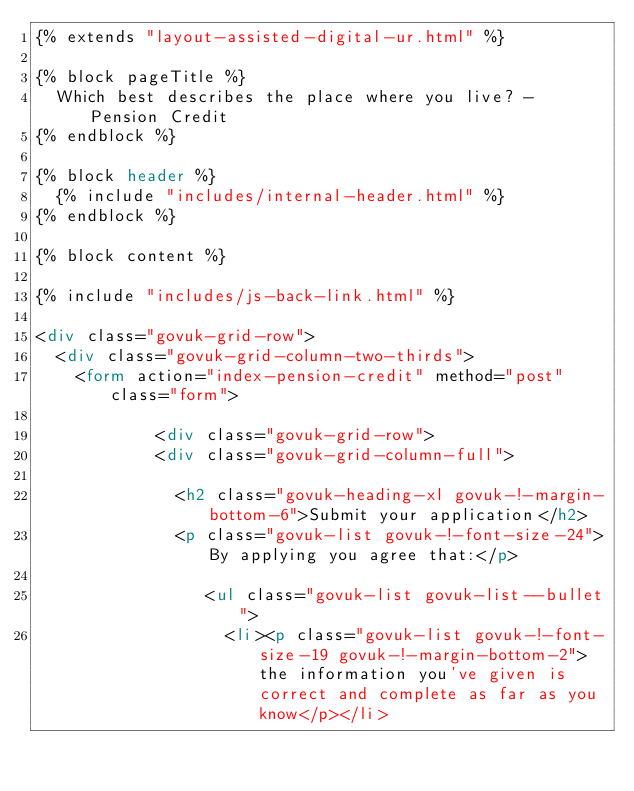Convert code to text. <code><loc_0><loc_0><loc_500><loc_500><_HTML_>{% extends "layout-assisted-digital-ur.html" %}

{% block pageTitle %}
  Which best describes the place where you live? - Pension Credit
{% endblock %}

{% block header %}
  {% include "includes/internal-header.html" %}
{% endblock %}

{% block content %}

{% include "includes/js-back-link.html" %}

<div class="govuk-grid-row">
  <div class="govuk-grid-column-two-thirds">
    <form action="index-pension-credit" method="post" class="form">

            <div class="govuk-grid-row">
            <div class="govuk-grid-column-full">

              <h2 class="govuk-heading-xl govuk-!-margin-bottom-6">Submit your application</h2>
              <p class="govuk-list govuk-!-font-size-24">By applying you agree that:</p>

                 <ul class="govuk-list govuk-list--bullet">
                   <li><p class="govuk-list govuk-!-font-size-19 govuk-!-margin-bottom-2">the information you've given is correct and complete as far as you know</p></li></code> 